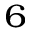<formula> <loc_0><loc_0><loc_500><loc_500>^ { 6 }</formula> 